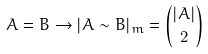<formula> <loc_0><loc_0><loc_500><loc_500>A = B \to | A \sim B | _ { m } = \binom { | A | } { 2 }</formula> 